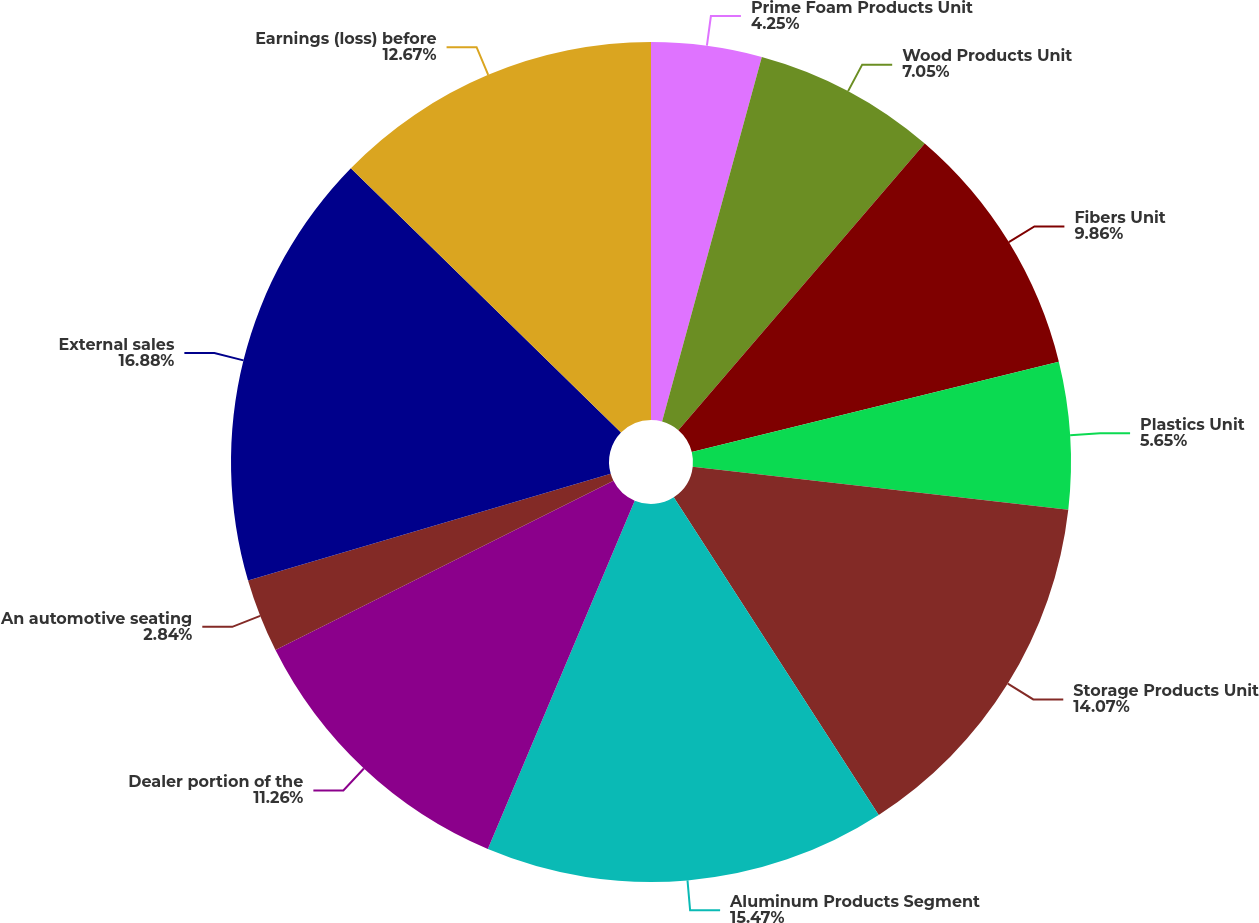Convert chart. <chart><loc_0><loc_0><loc_500><loc_500><pie_chart><fcel>Prime Foam Products Unit<fcel>Wood Products Unit<fcel>Fibers Unit<fcel>Plastics Unit<fcel>Storage Products Unit<fcel>Aluminum Products Segment<fcel>Dealer portion of the<fcel>An automotive seating<fcel>External sales<fcel>Earnings (loss) before<nl><fcel>4.25%<fcel>7.05%<fcel>9.86%<fcel>5.65%<fcel>14.07%<fcel>15.47%<fcel>11.26%<fcel>2.84%<fcel>16.88%<fcel>12.67%<nl></chart> 